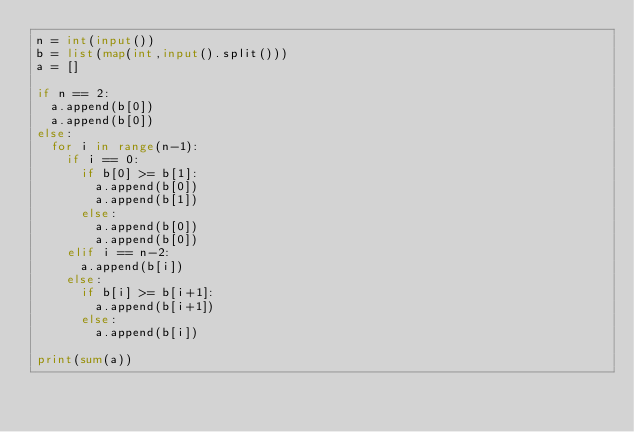Convert code to text. <code><loc_0><loc_0><loc_500><loc_500><_Python_>n = int(input())
b = list(map(int,input().split()))
a = []

if n == 2:
  a.append(b[0])
  a.append(b[0])
else:
  for i in range(n-1):
    if i == 0:
      if b[0] >= b[1]:
        a.append(b[0])
        a.append(b[1])
      else:
        a.append(b[0])
        a.append(b[0])
    elif i == n-2:
      a.append(b[i])
    else:
      if b[i] >= b[i+1]:
        a.append(b[i+1])
      else:
        a.append(b[i])

print(sum(a))</code> 